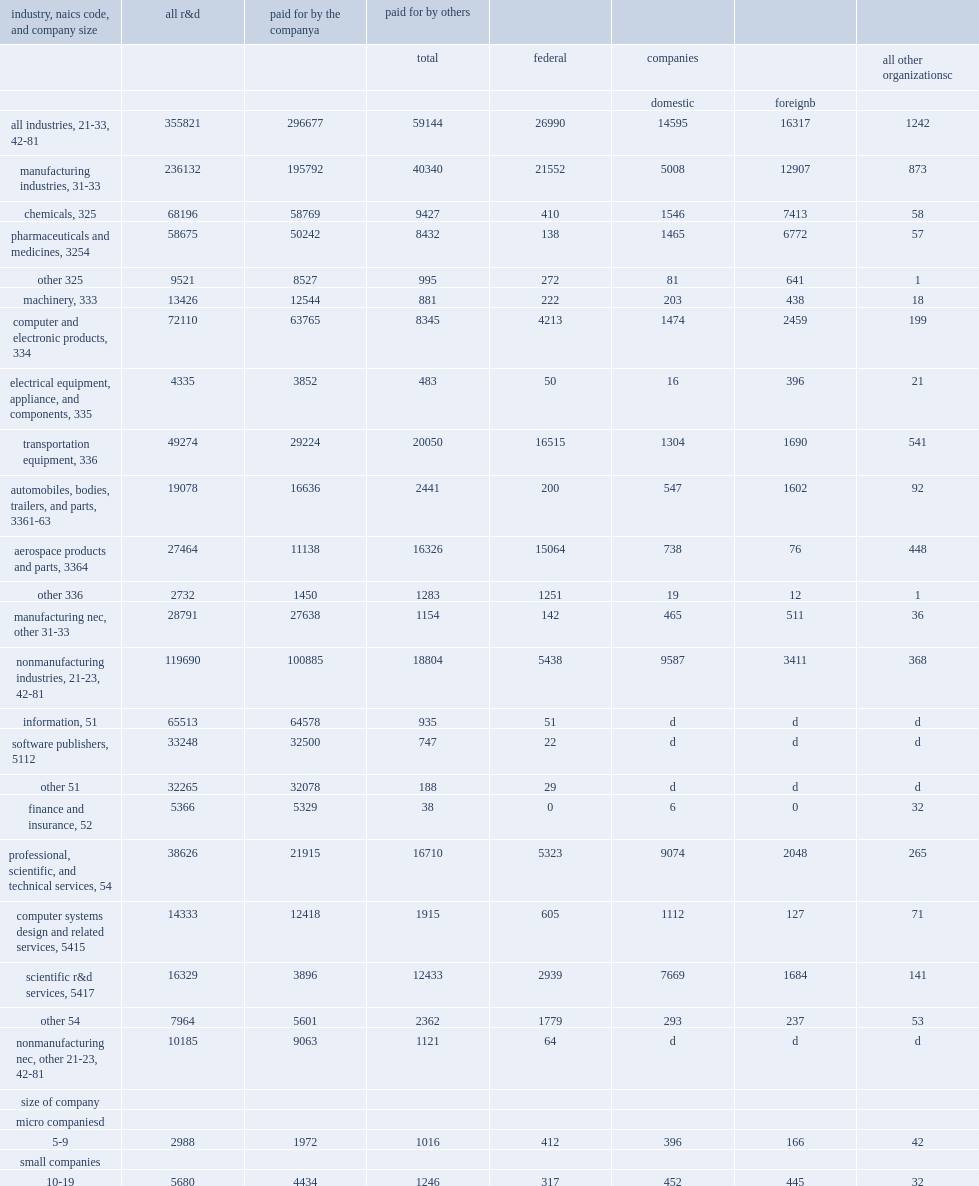I'm looking to parse the entire table for insights. Could you assist me with that? {'header': ['industry, naics code, and company size', 'all r&d', 'paid for by the companya', 'paid for by others', '', '', '', ''], 'rows': [['', '', '', 'total', 'federal', 'companies', '', 'all other organizationsc'], ['', '', '', '', '', 'domestic', 'foreignb', ''], ['all industries, 21-33, 42-81', '355821', '296677', '59144', '26990', '14595', '16317', '1242'], ['manufacturing industries, 31-33', '236132', '195792', '40340', '21552', '5008', '12907', '873'], ['chemicals, 325', '68196', '58769', '9427', '410', '1546', '7413', '58'], ['pharmaceuticals and medicines, 3254', '58675', '50242', '8432', '138', '1465', '6772', '57'], ['other 325', '9521', '8527', '995', '272', '81', '641', '1'], ['machinery, 333', '13426', '12544', '881', '222', '203', '438', '18'], ['computer and electronic products, 334', '72110', '63765', '8345', '4213', '1474', '2459', '199'], ['electrical equipment, appliance, and components, 335', '4335', '3852', '483', '50', '16', '396', '21'], ['transportation equipment, 336', '49274', '29224', '20050', '16515', '1304', '1690', '541'], ['automobiles, bodies, trailers, and parts, 3361-63', '19078', '16636', '2441', '200', '547', '1602', '92'], ['aerospace products and parts, 3364', '27464', '11138', '16326', '15064', '738', '76', '448'], ['other 336', '2732', '1450', '1283', '1251', '19', '12', '1'], ['manufacturing nec, other 31-33', '28791', '27638', '1154', '142', '465', '511', '36'], ['nonmanufacturing industries, 21-23, 42-81', '119690', '100885', '18804', '5438', '9587', '3411', '368'], ['information, 51', '65513', '64578', '935', '51', 'd', 'd', 'd'], ['software publishers, 5112', '33248', '32500', '747', '22', 'd', 'd', 'd'], ['other 51', '32265', '32078', '188', '29', 'd', 'd', 'd'], ['finance and insurance, 52', '5366', '5329', '38', '0', '6', '0', '32'], ['professional, scientific, and technical services, 54', '38626', '21915', '16710', '5323', '9074', '2048', '265'], ['computer systems design and related services, 5415', '14333', '12418', '1915', '605', '1112', '127', '71'], ['scientific r&d services, 5417', '16329', '3896', '12433', '2939', '7669', '1684', '141'], ['other 54', '7964', '5601', '2362', '1779', '293', '237', '53'], ['nonmanufacturing nec, other 21-23, 42-81', '10185', '9063', '1121', '64', 'd', 'd', 'd'], ['size of company', '', '', '', '', '', '', ''], ['micro companiesd', '', '', '', '', '', '', ''], ['5-9', '2988', '1972', '1016', '412', '396', '166', '42'], ['small companies', '', '', '', '', '', '', ''], ['10-19', '5680', '4434', '1246', '317', '452', '445', '32'], ['20-49', '10249', '7933', '2316', '1024', '767', '477', '48'], ['medium companies', '', '', '', '', '', '', ''], ['50-99', '11509', '8803', '2706', '532', '1279', '855', '40'], ['100-249', '13602', '11037', '2566', '1006', '723', '740', '97'], ['large companies', '', '', '', '', '', '', ''], ['250-499', '13553', '11368', '2185', '723', '449', '934', '79'], ['500-999', '15217', '13194', '2023', '183', '634', '1175', '31'], ['1,000-4,999', '58094', '48264', '9830', '1644', '1942', '6152', '92'], ['5,000-9,999', '38838', '34660', '4178', '891', '1143', '2050', '94'], ['10,000-24,999', '59328', '48450', '10878', '4244', '3519', '2936', '179'], ['25,000 or more', '126763', '106562', '20201', '16013', '3290', '388', '510']]} In 2015, how many percent did companies in manufacturing industries perform of domestic r&d, defined as r&d performed in the 50 states and washington, d.c.? 0.663626. In 2015, how many million dollars did companies in manufacturing industries perform of domestic r&d, defined as r&d performed in the 50 states and washington, d.c.? 236132.0. How many percnet did most of the funding was from these companies' own funds? 0.833782. How many million dollars of domesitc r&d did companies in nonmanufacturing industries perform? 119690.0. How many percnet did companies in nonmanufacturing industries perform? of total domestic r&d performance? 0.336377. Companies in nonmanufacturing industries performed $120 billion of domestic r&d, how many percent of which was paid for from companies' own funds? 0.842886. How many million dollars were paid for by others? 59144.0. Of the $59 million paid for by others, how many million dollars did the federal government account for? 26990.0. How many million dollars among external funders were foreign companies? 16317.0. Among external funders were foreign companies-including foreign parent companies of u.s. subsidiaries and other u.s. companies, how many million dollars in u.s. companies? 14595.0. 